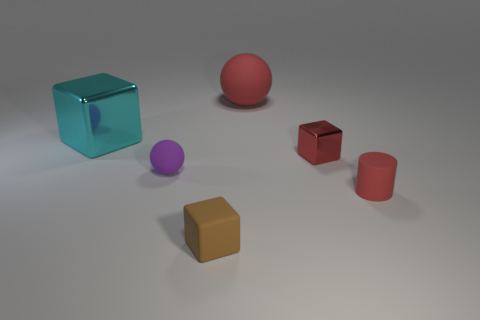Add 2 tiny brown things. How many objects exist? 8 Subtract all cylinders. How many objects are left? 5 Subtract all red metallic cubes. Subtract all small red cylinders. How many objects are left? 4 Add 5 balls. How many balls are left? 7 Add 5 small balls. How many small balls exist? 6 Subtract 0 blue cylinders. How many objects are left? 6 